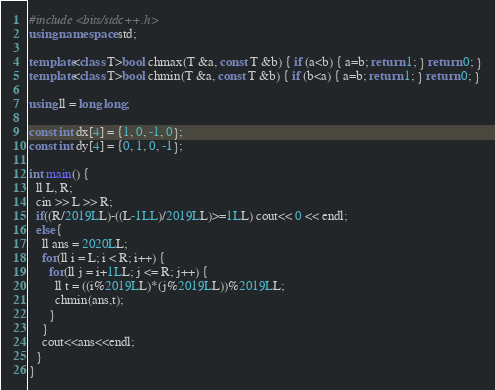Convert code to text. <code><loc_0><loc_0><loc_500><loc_500><_C++_>#include <bits/stdc++.h>
using namespace std;

template<class T>bool chmax(T &a, const T &b) { if (a<b) { a=b; return 1; } return 0; }
template<class T>bool chmin(T &a, const T &b) { if (b<a) { a=b; return 1; } return 0; }

using ll = long long;

const int dx[4] = {1, 0, -1, 0};
const int dy[4] = {0, 1, 0, -1};

int main() {
  ll L, R;
  cin >> L >> R;
  if((R/2019LL)-((L-1LL)/2019LL)>=1LL) cout<< 0 << endl;
  else{
    ll ans = 2020LL;
    for(ll i = L; i < R; i++) {
      for(ll j = i+1LL; j <= R; j++) {
        ll t = ((i%2019LL)*(j%2019LL))%2019LL;
        chmin(ans,t);
      }
    }
    cout<<ans<<endl;
  }
}</code> 